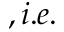Convert formula to latex. <formula><loc_0><loc_0><loc_500><loc_500>, i . e .</formula> 